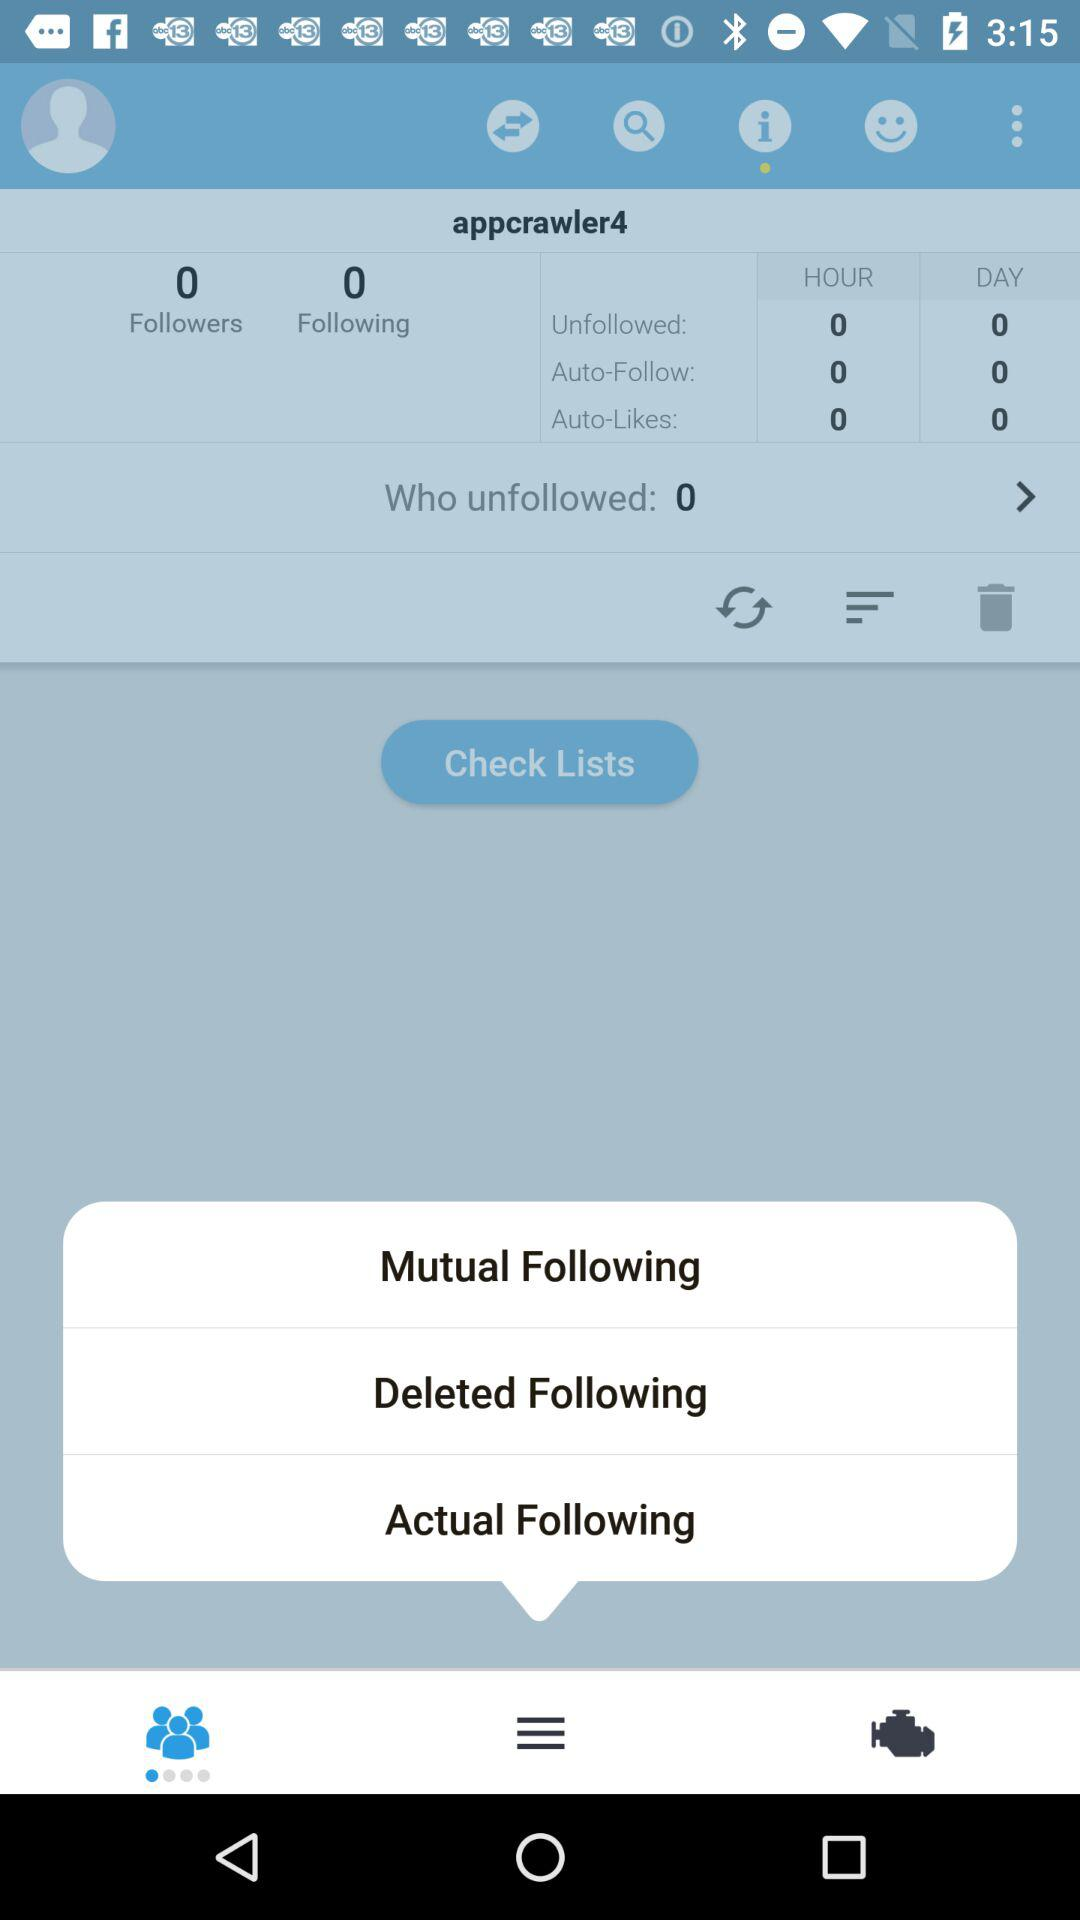How many people follow "appcrawler4"? The number of people who follow "appcrawler4" is 0. 